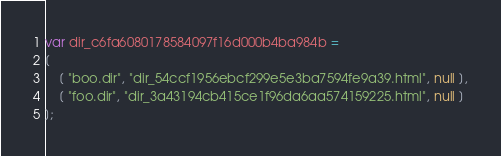Convert code to text. <code><loc_0><loc_0><loc_500><loc_500><_JavaScript_>var dir_c6fa6080178584097f16d000b4ba984b =
[
    [ "boo.dir", "dir_54ccf1956ebcf299e5e3ba7594fe9a39.html", null ],
    [ "foo.dir", "dir_3a43194cb415ce1f96da6aa574159225.html", null ]
];</code> 